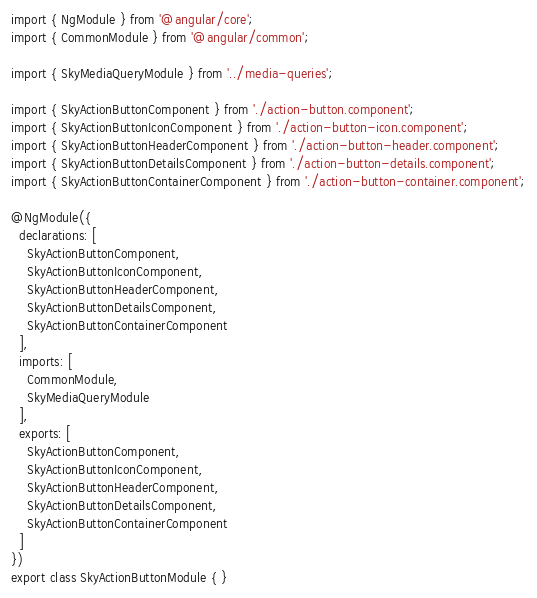<code> <loc_0><loc_0><loc_500><loc_500><_TypeScript_>import { NgModule } from '@angular/core';
import { CommonModule } from '@angular/common';

import { SkyMediaQueryModule } from '../media-queries';

import { SkyActionButtonComponent } from './action-button.component';
import { SkyActionButtonIconComponent } from './action-button-icon.component';
import { SkyActionButtonHeaderComponent } from './action-button-header.component';
import { SkyActionButtonDetailsComponent } from './action-button-details.component';
import { SkyActionButtonContainerComponent } from './action-button-container.component';

@NgModule({
  declarations: [
    SkyActionButtonComponent,
    SkyActionButtonIconComponent,
    SkyActionButtonHeaderComponent,
    SkyActionButtonDetailsComponent,
    SkyActionButtonContainerComponent
  ],
  imports: [
    CommonModule,
    SkyMediaQueryModule
  ],
  exports: [
    SkyActionButtonComponent,
    SkyActionButtonIconComponent,
    SkyActionButtonHeaderComponent,
    SkyActionButtonDetailsComponent,
    SkyActionButtonContainerComponent
  ]
})
export class SkyActionButtonModule { }
</code> 